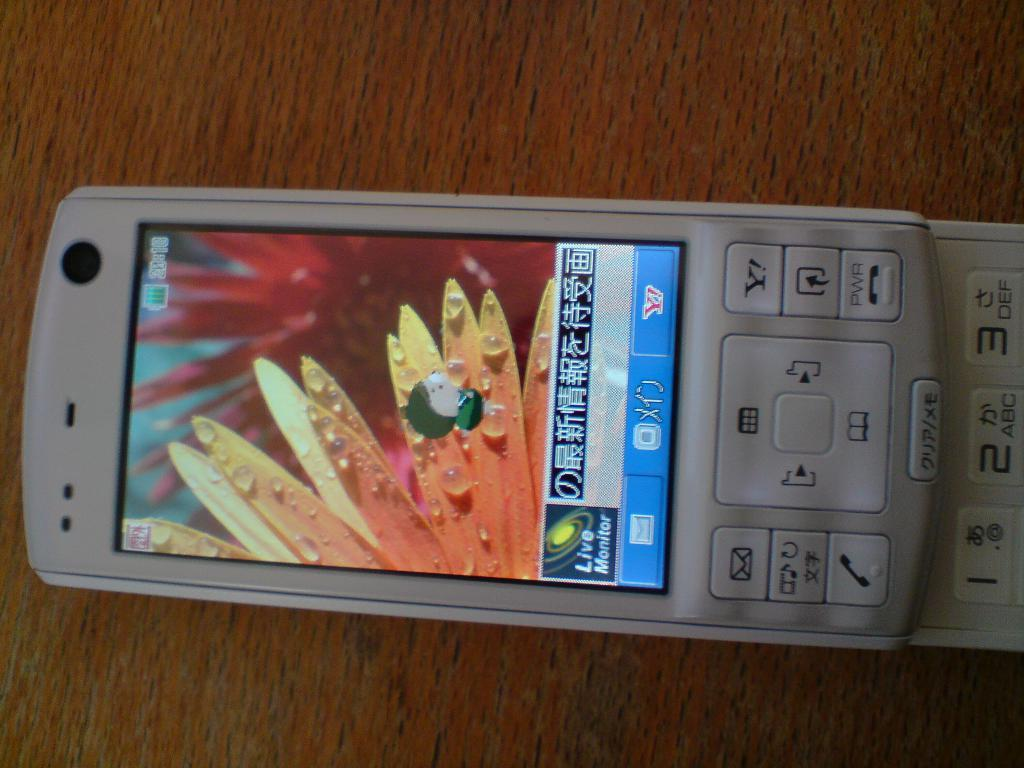What electronic device is visible in the image? There is a mobile phone in the image. Where is the mobile phone located? The mobile phone is on a wooden table. What type of insect is crawling on the mobile phone in the image? There is no insect present on the mobile phone in the image. 